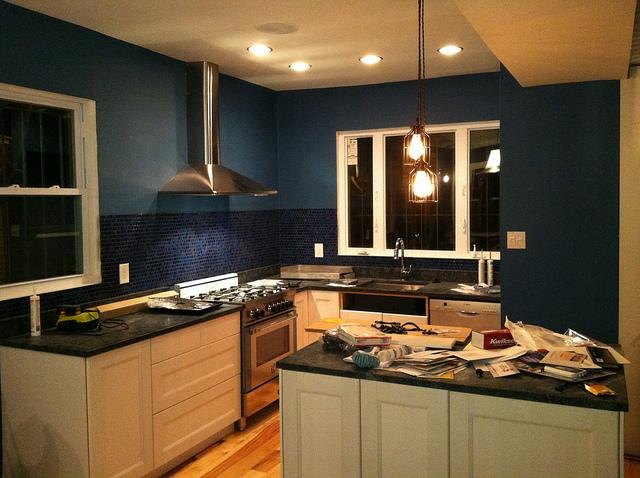What kind of backsplash has been attached to the wall? Please explain your reasoning. glass. These are small tiles that come in sheets to help them apply to the wall easier and are easy to care for 